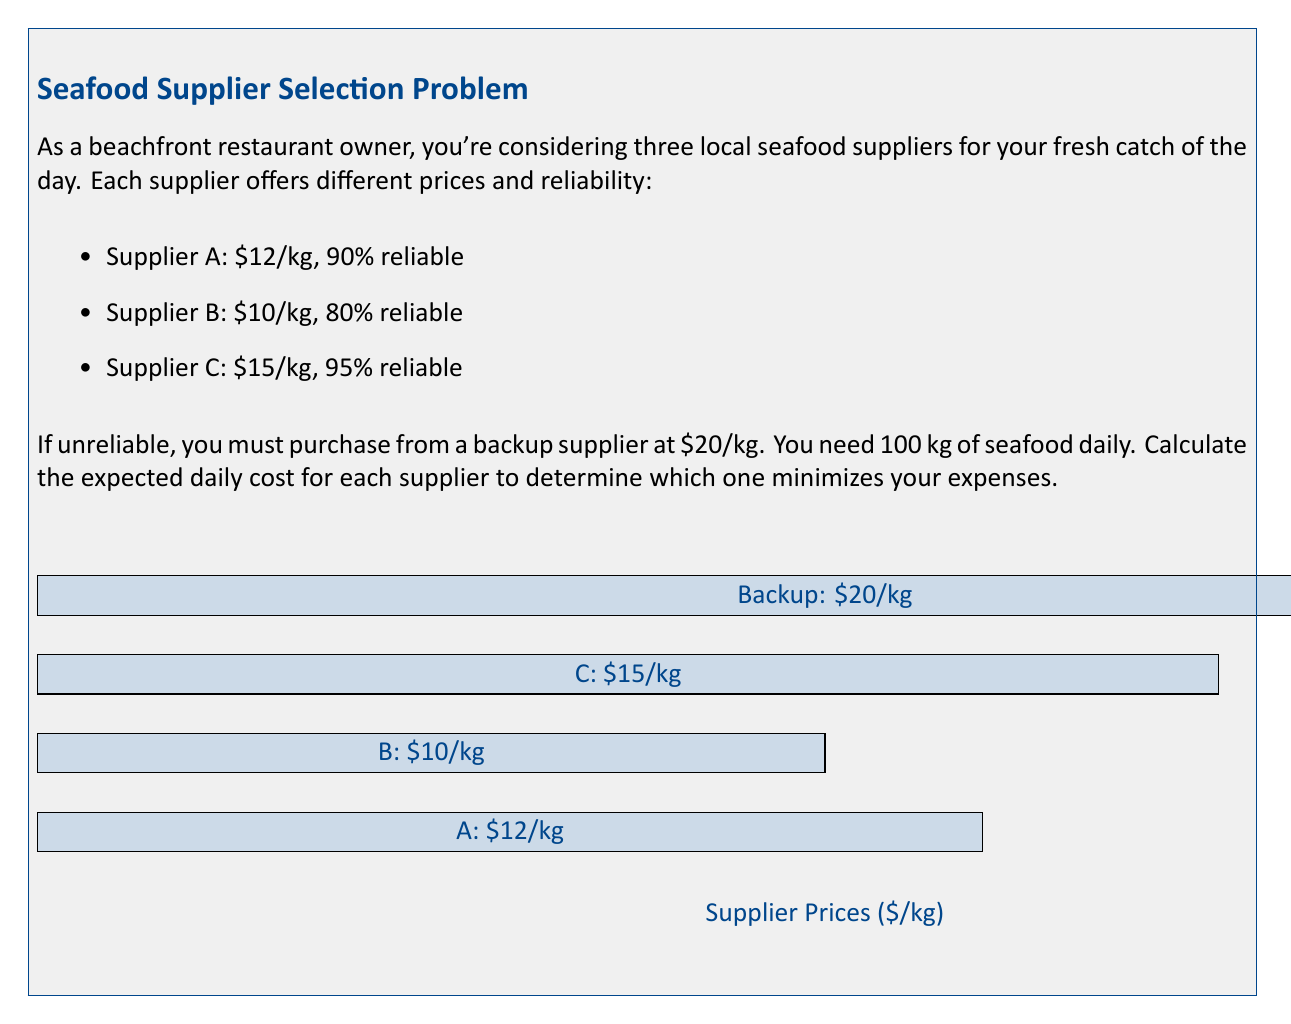What is the answer to this math problem? Let's calculate the expected daily cost for each supplier:

1. Supplier A:
   - Probability of being reliable: 90% = 0.9
   - Expected cost = (Reliable cost × Probability) + (Backup cost × (1 - Probability))
   $$E(A) = (100 \times 12 \times 0.9) + (100 \times 20 \times 0.1)$$
   $$E(A) = 1080 + 200 = 1280$$

2. Supplier B:
   - Probability of being reliable: 80% = 0.8
   $$E(B) = (100 \times 10 \times 0.8) + (100 \times 20 \times 0.2)$$
   $$E(B) = 800 + 400 = 1200$$

3. Supplier C:
   - Probability of being reliable: 95% = 0.95
   $$E(C) = (100 \times 15 \times 0.95) + (100 \times 20 \times 0.05)$$
   $$E(C) = 1425 + 100 = 1525$$

Comparing the expected daily costs:
Supplier A: $1280
Supplier B: $1200
Supplier C: $1525

Therefore, Supplier B offers the lowest expected daily cost.
Answer: Supplier B, with an expected daily cost of $1200. 